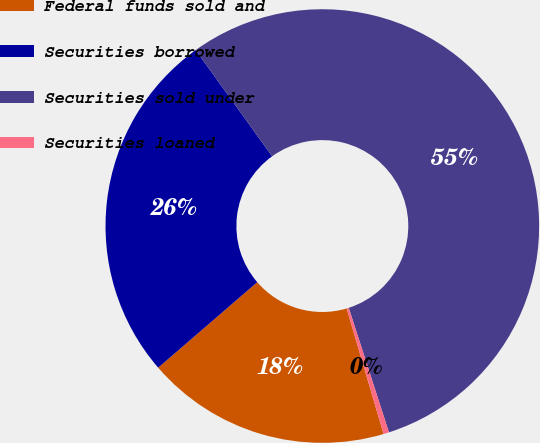Convert chart. <chart><loc_0><loc_0><loc_500><loc_500><pie_chart><fcel>Federal funds sold and<fcel>Securities borrowed<fcel>Securities sold under<fcel>Securities loaned<nl><fcel>18.23%<fcel>26.4%<fcel>54.96%<fcel>0.41%<nl></chart> 